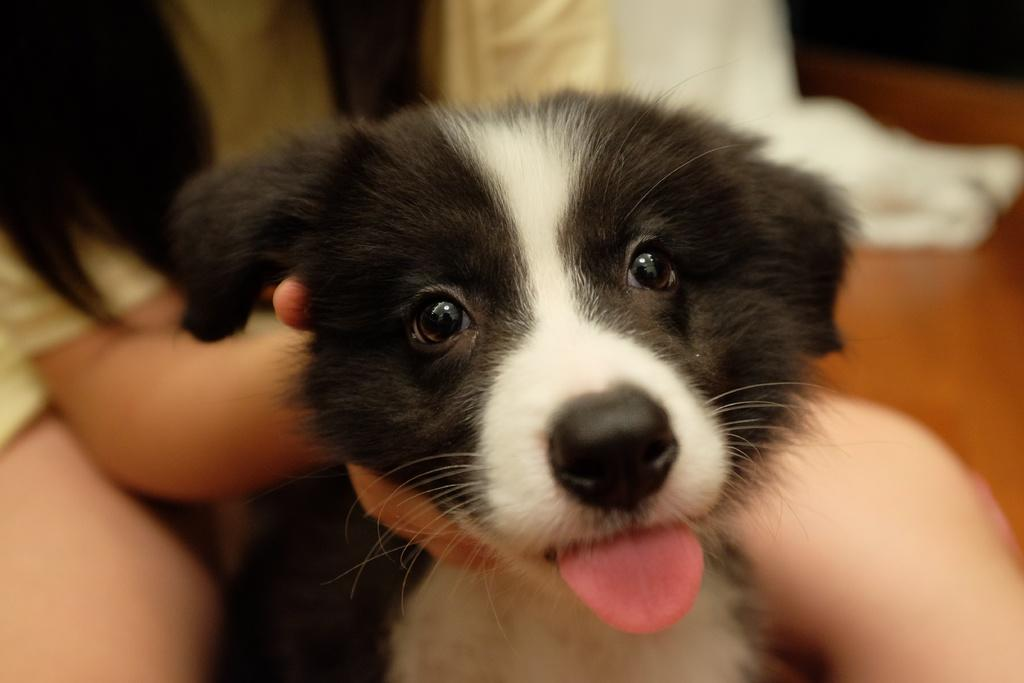What type of animal is present in the image? There is a dog in the image. What is the person in the image doing? The person is sitting on a chair in the image. What type of coach can be seen in the background of the image? There is no coach present in the image; it only features a dog and a person sitting on a chair. 